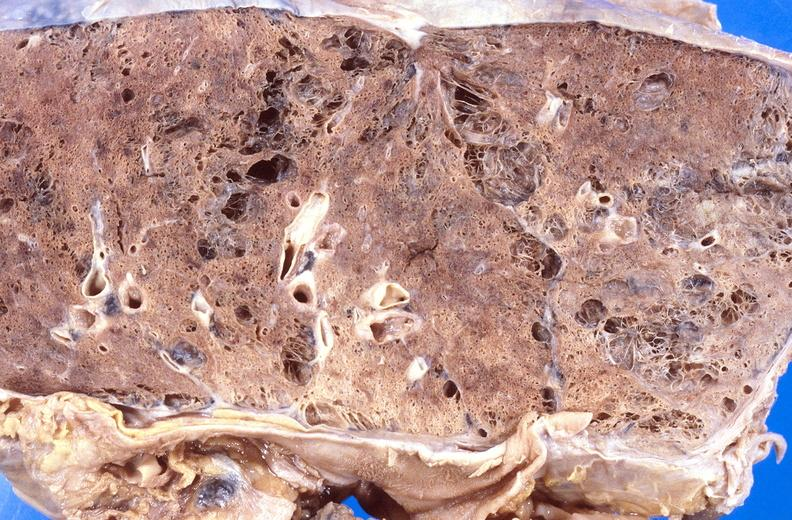does lymph node show cryptococcal pneumonia?
Answer the question using a single word or phrase. No 